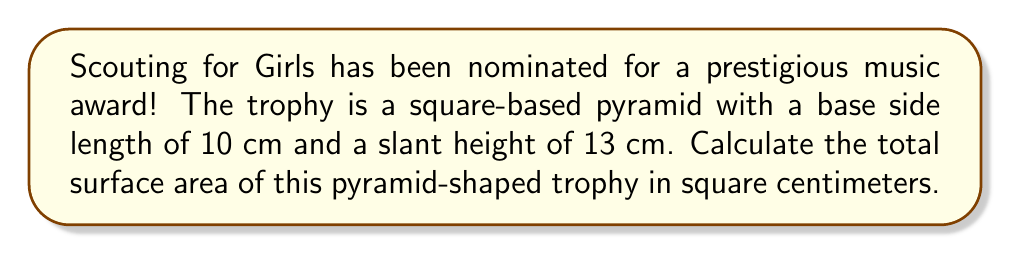What is the answer to this math problem? Let's approach this step-by-step:

1) The surface area of a square-based pyramid consists of two parts:
   a) The area of the square base
   b) The area of the four triangular faces

2) For the square base:
   - Area of base = side length² = $10^2 = 100$ cm²

3) For the triangular faces:
   - We need to find the area of one triangular face and multiply by 4
   - The area of a triangle is given by $\frac{1}{2} \times base \times height$
   - Here, the base is the side of the square (10 cm) and the height is the slant height (13 cm)
   - Area of one face = $\frac{1}{2} \times 10 \times 13 = 65$ cm²
   - Area of all four faces = $65 \times 4 = 260$ cm²

4) Total surface area:
   $$ \text{Total Surface Area} = \text{Area of base} + \text{Area of four faces} $$
   $$ \text{Total Surface Area} = 100 + 260 = 360 \text{ cm}^2 $$

[asy]
import geometry;

size(200);
pair A = (0,0), B = (4,0), C = (4,4), D = (0,4), E = (2,5);
draw(A--B--C--D--cycle);
draw(A--E--C);
draw(B--E);
draw(D--E,dashed);
label("10 cm", (A+B)/2, S);
label("13 cm", (A+E)/2, NW);
</asy]
Answer: 360 cm² 